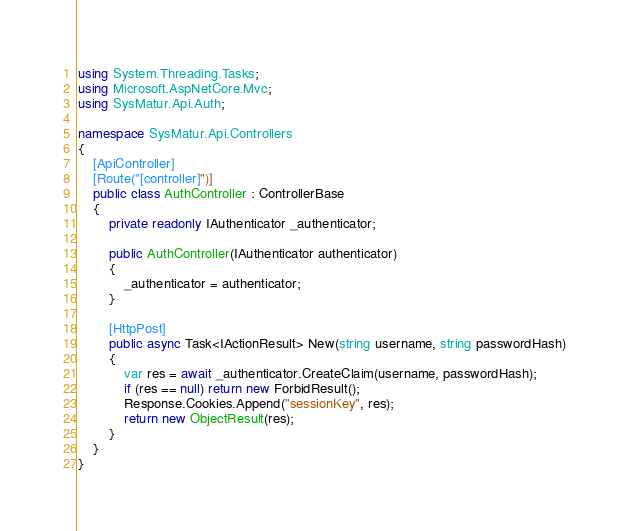<code> <loc_0><loc_0><loc_500><loc_500><_C#_>using System.Threading.Tasks;
using Microsoft.AspNetCore.Mvc;
using SysMatur.Api.Auth;

namespace SysMatur.Api.Controllers
{
    [ApiController]
    [Route("[controller]")]
    public class AuthController : ControllerBase
    {
        private readonly IAuthenticator _authenticator;

        public AuthController(IAuthenticator authenticator)
        {
            _authenticator = authenticator;
        }

        [HttpPost]
        public async Task<IActionResult> New(string username, string passwordHash)
        {
            var res = await _authenticator.CreateClaim(username, passwordHash);
            if (res == null) return new ForbidResult();
            Response.Cookies.Append("sessionKey", res);
            return new ObjectResult(res);
        }
    }
}</code> 